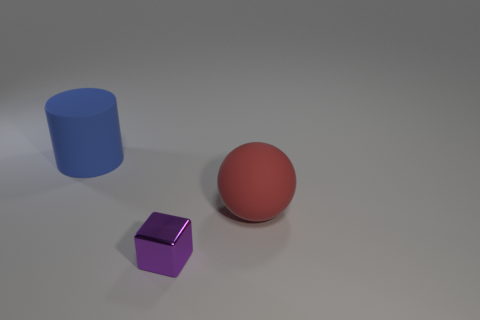What number of other things are there of the same shape as the small metallic object?
Provide a succinct answer. 0. There is another object that is the same size as the blue thing; what color is it?
Ensure brevity in your answer.  Red. What number of other small purple objects are the same shape as the purple metallic object?
Your answer should be very brief. 0. Is the material of the large object on the right side of the blue matte thing the same as the tiny purple cube?
Your answer should be compact. No. How many cylinders are purple things or red objects?
Keep it short and to the point. 0. There is a big matte thing on the right side of the large matte thing behind the big rubber sphere on the right side of the big rubber cylinder; what is its shape?
Offer a very short reply. Sphere. How many other metallic objects are the same size as the purple metal object?
Your response must be concise. 0. There is a big matte object left of the purple metallic thing; are there any red rubber balls behind it?
Ensure brevity in your answer.  No. How many objects are small yellow metal objects or large rubber objects?
Ensure brevity in your answer.  2. What color is the rubber thing behind the big thing in front of the big thing that is to the left of the big matte sphere?
Your answer should be very brief. Blue. 